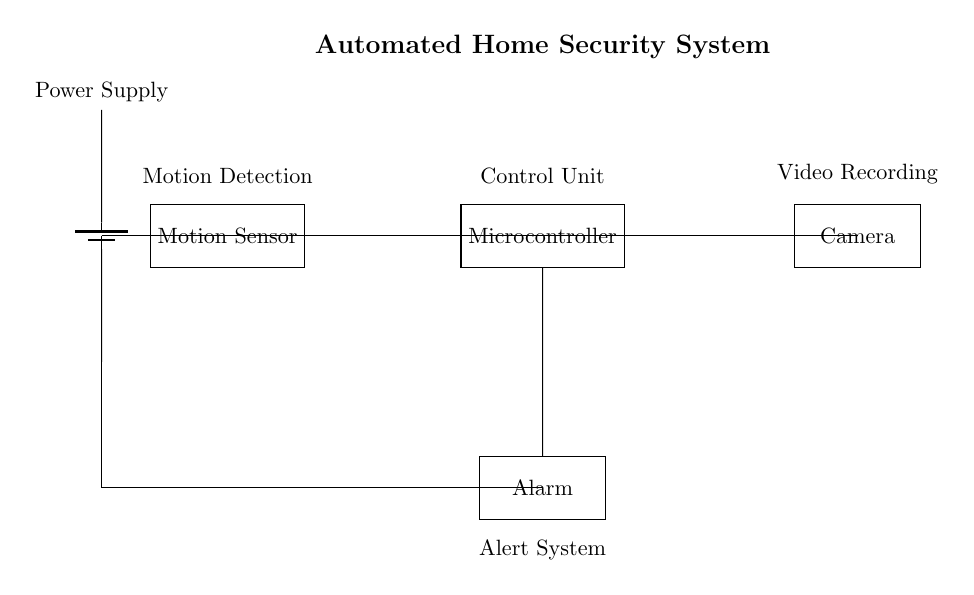What component is responsible for detecting motion? The motion sensor is identified in the diagram as it is marked specifically for motion detection. It receives input from the surrounding environment to trigger actions based on movement.
Answer: Motion Sensor Which component performs video recording? The camera is indicated in the diagram as the device that captures video. It's connected to the microcontroller, showing that it is operational when motion is detected.
Answer: Camera What role does the microcontroller play in this circuit? The microcontroller acts as the control unit, processing inputs from the motion sensor and controlling outputs to the camera and alarm. It orchestrates the overall operation of the security system.
Answer: Control Unit How does the power supply connect to the motion sensor? The power supply is connected to the motion sensor through a line that denotes voltage, providing necessary energy for its operation. This connection is essential for the sensor's functionality.
Answer: Power Supply What activates the alarm system? The alarm system is activated by the microcontroller in response to input from the motion sensor. When motion is detected, the control unit sends a signal to trigger the alarm, indicating a potential security breach.
Answer: Microcontroller Which components are connected directly to the microcontroller? The microcontroller is directly connected to the motion sensor, camera, and alarm. This configuration allows it to control both the recording and alert functions when motion detection occurs.
Answer: Motion Sensor, Camera, Alarm How is the power supply distributed in the circuit? The power supply distributes voltage to all three main components: the motion sensor, microcontroller, and alarm system, ensuring they all receive the necessary energy to function as a cohesive system.
Answer: All components 